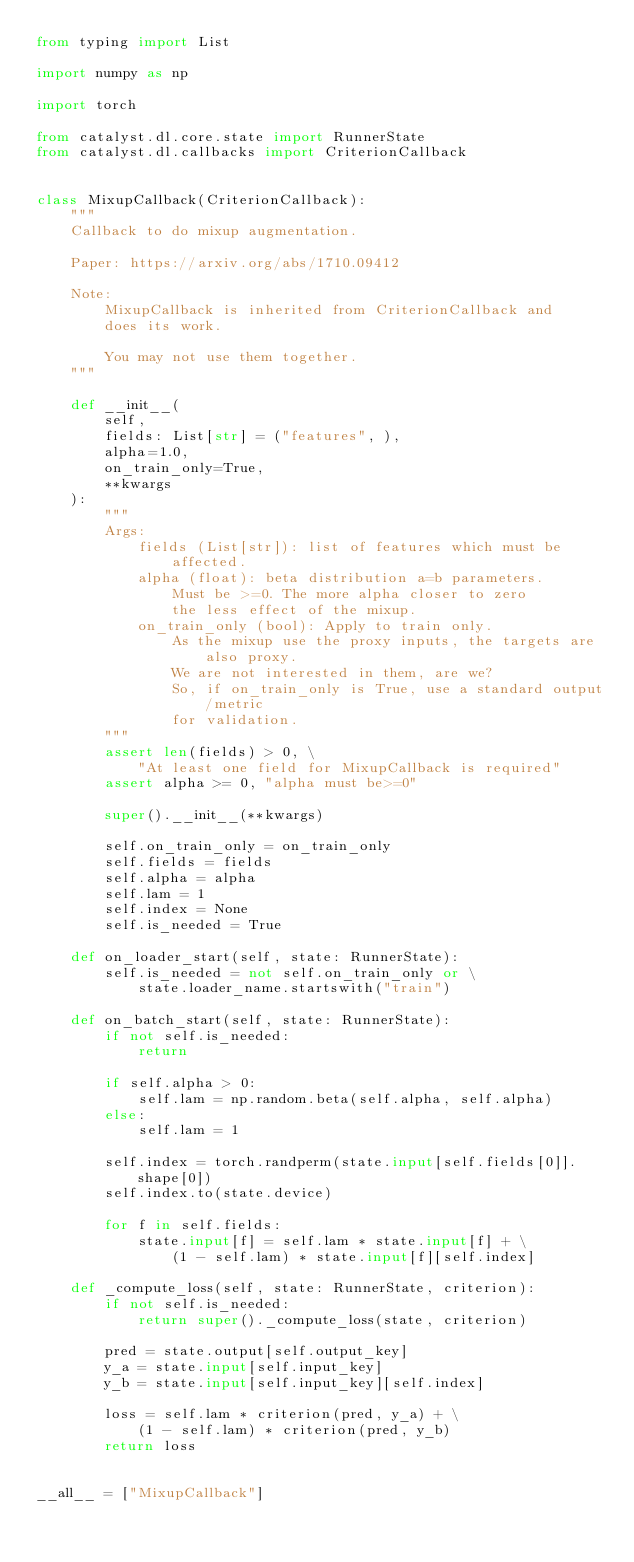<code> <loc_0><loc_0><loc_500><loc_500><_Python_>from typing import List

import numpy as np

import torch

from catalyst.dl.core.state import RunnerState
from catalyst.dl.callbacks import CriterionCallback


class MixupCallback(CriterionCallback):
    """
    Callback to do mixup augmentation.

    Paper: https://arxiv.org/abs/1710.09412

    Note:
        MixupCallback is inherited from CriterionCallback and
        does its work.

        You may not use them together.
    """

    def __init__(
        self,
        fields: List[str] = ("features", ),
        alpha=1.0,
        on_train_only=True,
        **kwargs
    ):
        """
        Args:
            fields (List[str]): list of features which must be affected.
            alpha (float): beta distribution a=b parameters.
                Must be >=0. The more alpha closer to zero
                the less effect of the mixup.
            on_train_only (bool): Apply to train only.
                As the mixup use the proxy inputs, the targets are also proxy.
                We are not interested in them, are we?
                So, if on_train_only is True, use a standard output/metric
                for validation.
        """
        assert len(fields) > 0, \
            "At least one field for MixupCallback is required"
        assert alpha >= 0, "alpha must be>=0"

        super().__init__(**kwargs)

        self.on_train_only = on_train_only
        self.fields = fields
        self.alpha = alpha
        self.lam = 1
        self.index = None
        self.is_needed = True

    def on_loader_start(self, state: RunnerState):
        self.is_needed = not self.on_train_only or \
            state.loader_name.startswith("train")

    def on_batch_start(self, state: RunnerState):
        if not self.is_needed:
            return

        if self.alpha > 0:
            self.lam = np.random.beta(self.alpha, self.alpha)
        else:
            self.lam = 1

        self.index = torch.randperm(state.input[self.fields[0]].shape[0])
        self.index.to(state.device)

        for f in self.fields:
            state.input[f] = self.lam * state.input[f] + \
                (1 - self.lam) * state.input[f][self.index]

    def _compute_loss(self, state: RunnerState, criterion):
        if not self.is_needed:
            return super()._compute_loss(state, criterion)

        pred = state.output[self.output_key]
        y_a = state.input[self.input_key]
        y_b = state.input[self.input_key][self.index]

        loss = self.lam * criterion(pred, y_a) + \
            (1 - self.lam) * criterion(pred, y_b)
        return loss


__all__ = ["MixupCallback"]
</code> 